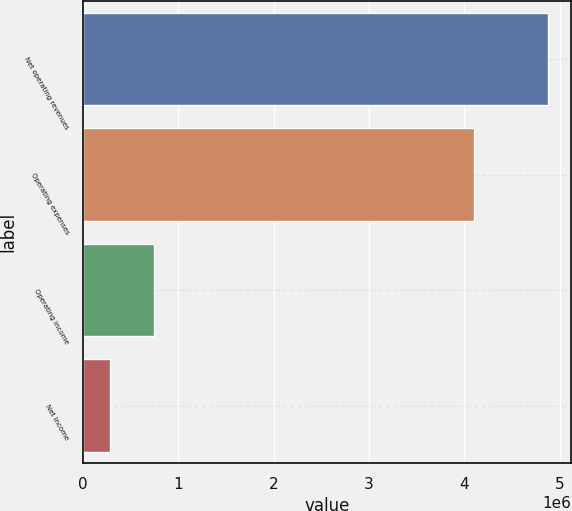Convert chart to OTSL. <chart><loc_0><loc_0><loc_500><loc_500><bar_chart><fcel>Net operating revenues<fcel>Operating expenses<fcel>Operating income<fcel>Net income<nl><fcel>4.88066e+06<fcel>4.1054e+06<fcel>748788<fcel>289691<nl></chart> 